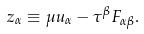<formula> <loc_0><loc_0><loc_500><loc_500>z _ { \alpha } \equiv \mu u _ { \alpha } - \tau ^ { \beta } F _ { \alpha \beta } .</formula> 